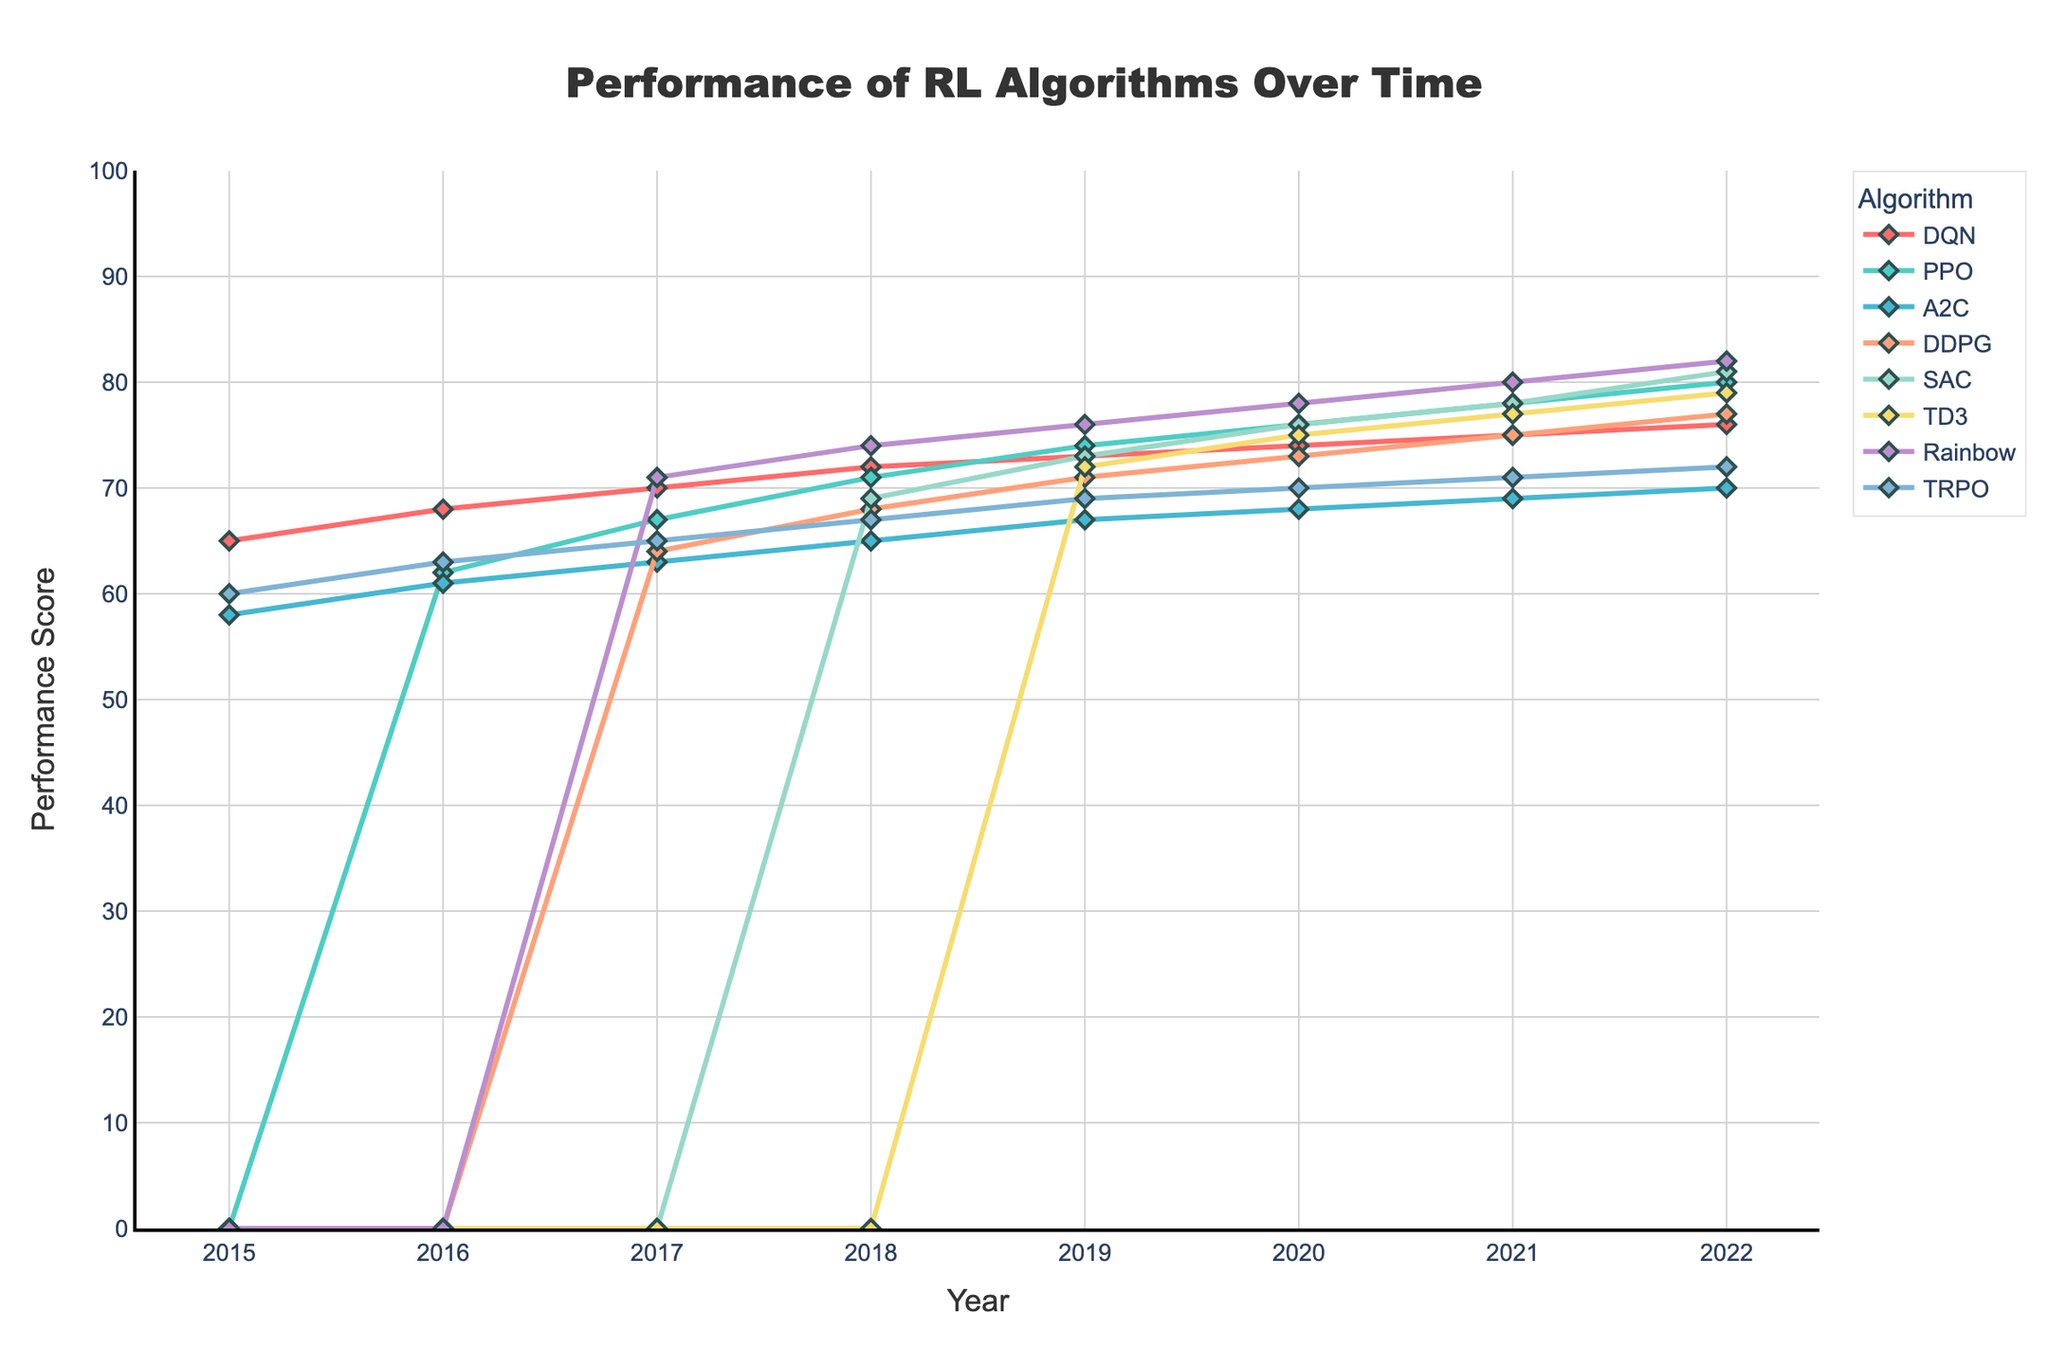Which algorithm had the highest performance in 2022? By looking at the figure, the algorithm represented by the highest point on the performance axis in 2022 is Rainbow.
Answer: Rainbow Between PPO and SAC, which algorithm showed a greater improvement from 2016 to 2022? SAC started appearing in 2018 with a performance score of 69 and reached 81 in 2022. PPO had a score of 62 in 2016 and reached 80 in 2022. PPO improved by 18 points (62 to 80), while SAC improved by 12 points (69 to 81).
Answer: PPO What was the performance difference between DQN and A2C in 2020? In 2020, DQN had a performance score of 74 and A2C had a score of 68. The difference is 74 - 68 = 6.
Answer: 6 Which two algorithms had the same performance in any year? In 2019, both PPO and TRPO had a performance score of 74.
Answer: PPO and TRPO How much did the performance of TD3 increase from 2019 to 2022? TD3 is not listed before 2019, but shows up in 2019 with a performance of 72 and 79 in 2022. Therefore, the increase is 79 - 72 = 7.
Answer: 7 What is the average performance of DDPG from 2019 to 2022? The performance scores for DDPG are 71 (2019), 73 (2020), 75 (2021), and 77 (2022). The average = (71 + 73 + 75 + 77) / 4 = 296 / 4 = 74.
Answer: 74 Which algorithm showed the most consistent performance increase year-over-year? By analyzing the trends, DQN shows a consistent year-over-year increase without any drops, starting from 65 in 2015 and reaching 76 in 2022 with no declines.
Answer: DQN In which year did A2C surpass DQN for the first time? A2C did not surpass DQN in any year according to the provided data; DQN always had a higher performance score each year.
Answer: Never What is the total performance improvement of Rainbow from its first appearance to 2022? Rainbow appears in 2017 with a performance score of 71 and increases to 82 in 2022. The total improvement is 82 - 71 = 11.
Answer: 11 